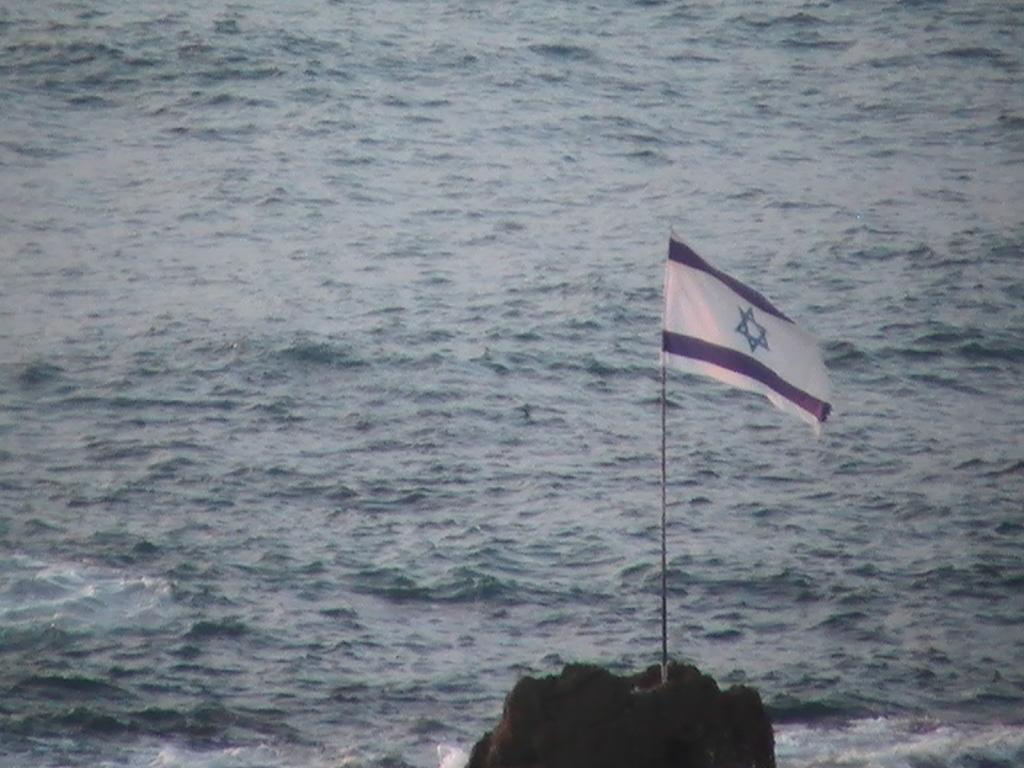What object is attached to the stick in the image? There is a flag attached to the stick in the image. What can be seen in the background of the image? Water is visible in the image. What type of polish is being applied to the lettuce in the image? There is no lettuce or polish present in the image; it only features a flag with a stick and water. 